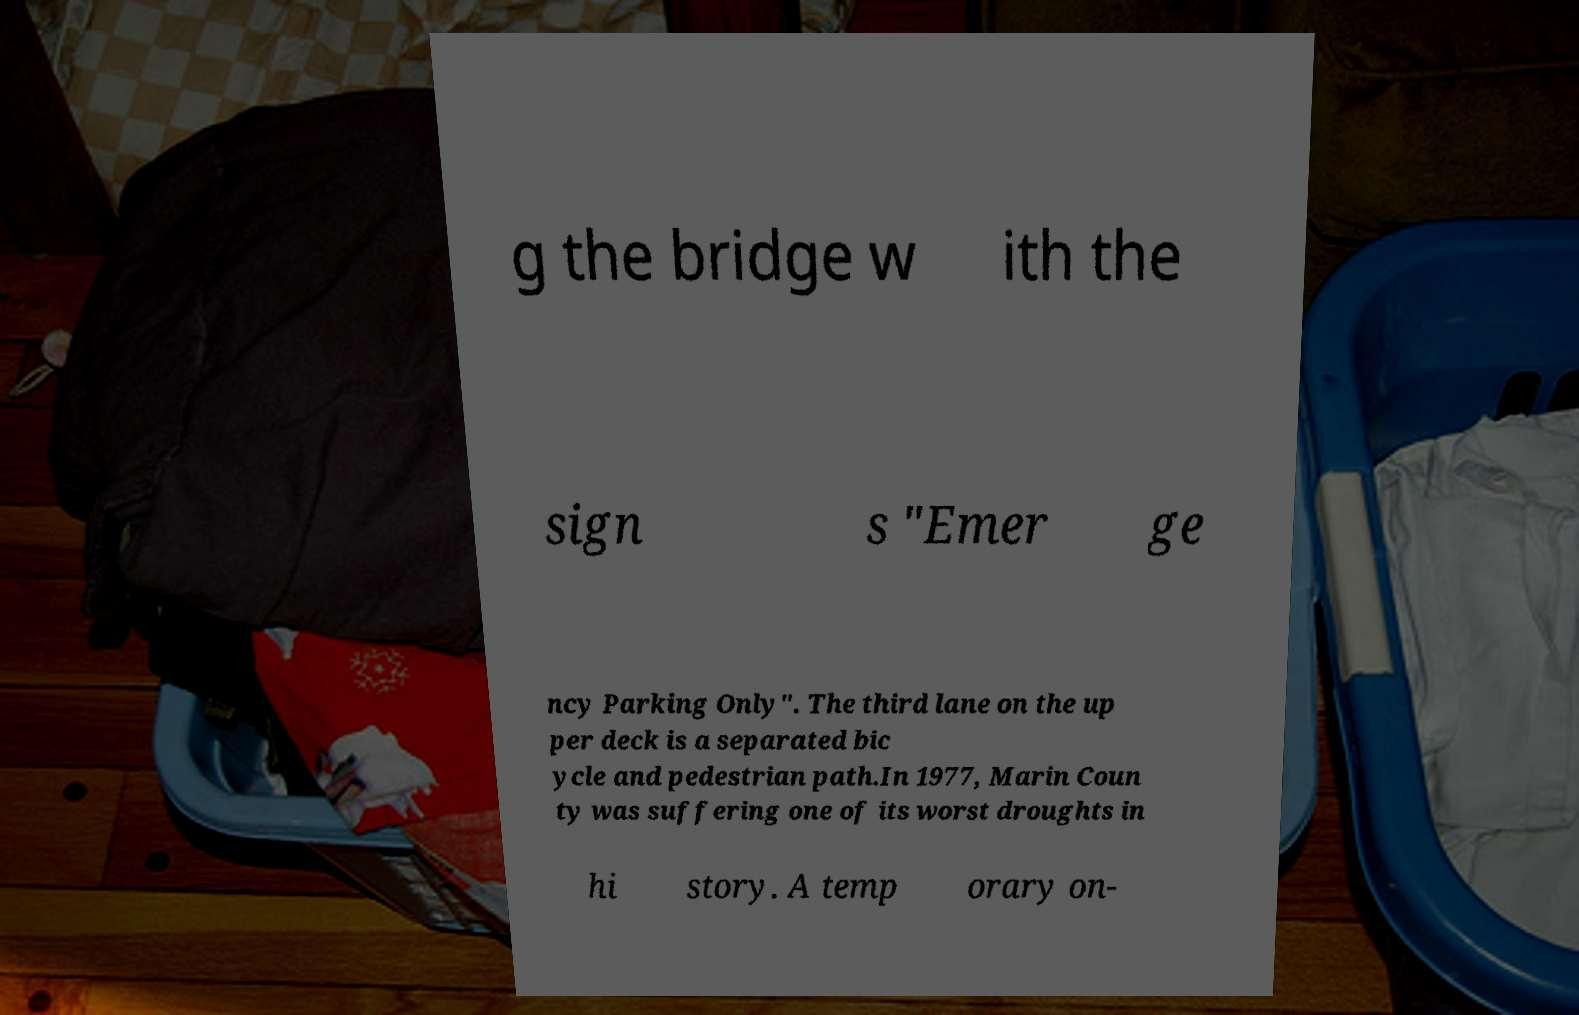Please identify and transcribe the text found in this image. g the bridge w ith the sign s "Emer ge ncy Parking Only". The third lane on the up per deck is a separated bic ycle and pedestrian path.In 1977, Marin Coun ty was suffering one of its worst droughts in hi story. A temp orary on- 